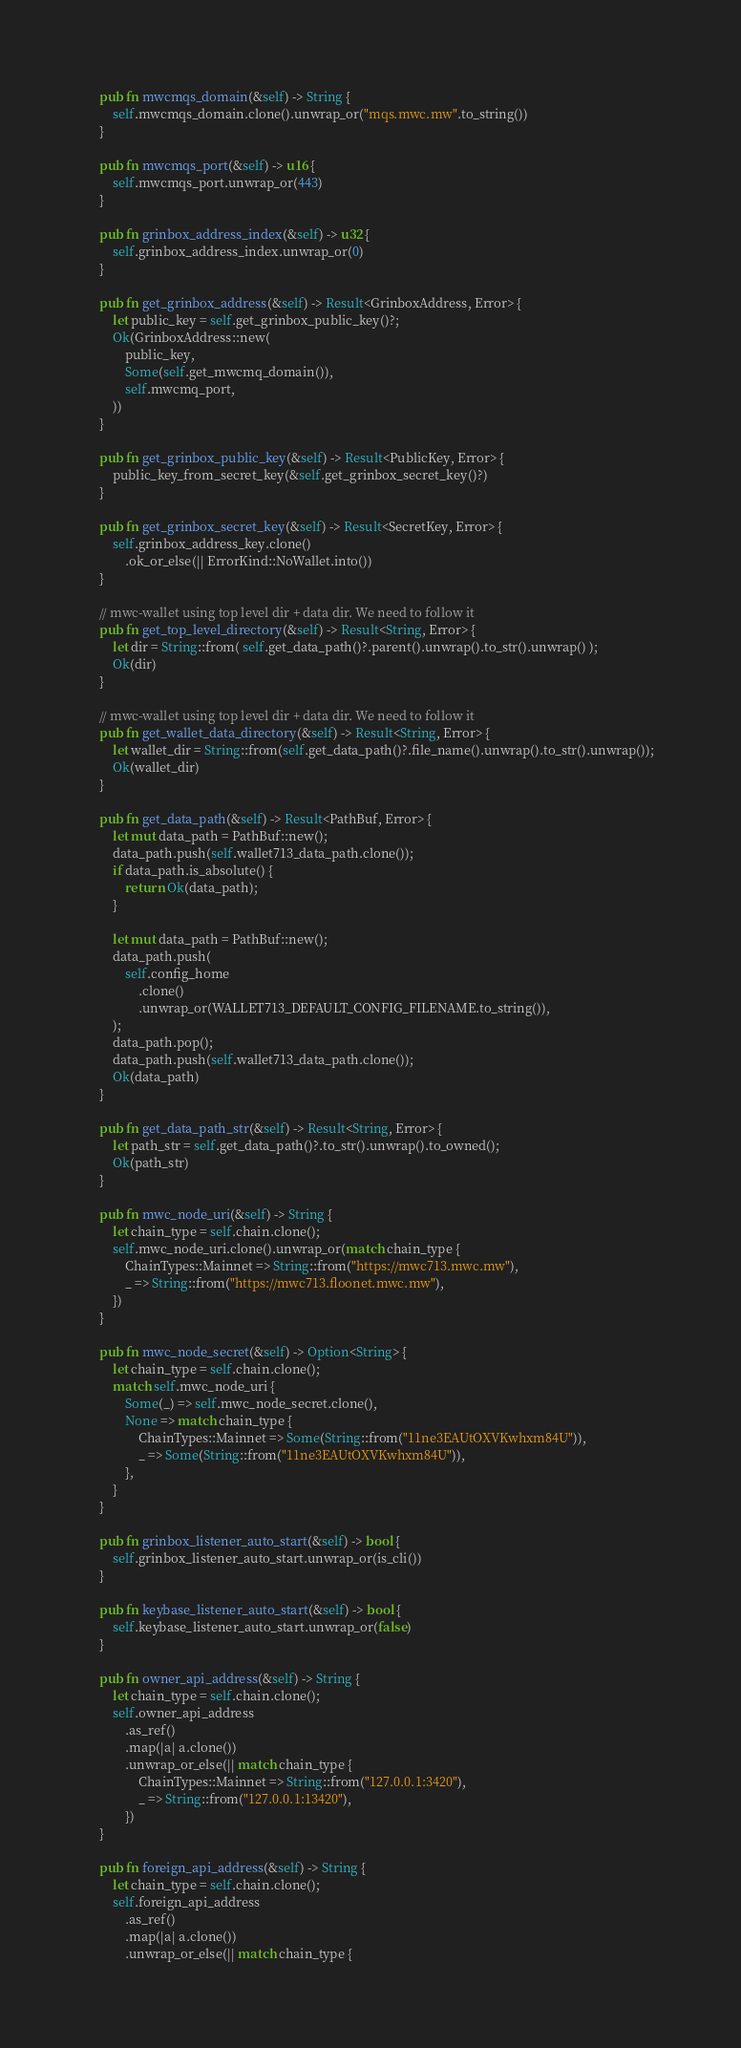Convert code to text. <code><loc_0><loc_0><loc_500><loc_500><_Rust_>
    pub fn mwcmqs_domain(&self) -> String {
        self.mwcmqs_domain.clone().unwrap_or("mqs.mwc.mw".to_string())
    }

    pub fn mwcmqs_port(&self) -> u16 {
        self.mwcmqs_port.unwrap_or(443)
    }

    pub fn grinbox_address_index(&self) -> u32 {
        self.grinbox_address_index.unwrap_or(0)
    }

    pub fn get_grinbox_address(&self) -> Result<GrinboxAddress, Error> {
        let public_key = self.get_grinbox_public_key()?;
        Ok(GrinboxAddress::new(
            public_key,
            Some(self.get_mwcmq_domain()),
            self.mwcmq_port,
        ))
    }

    pub fn get_grinbox_public_key(&self) -> Result<PublicKey, Error> {
        public_key_from_secret_key(&self.get_grinbox_secret_key()?)
    }

    pub fn get_grinbox_secret_key(&self) -> Result<SecretKey, Error> {
        self.grinbox_address_key.clone()
            .ok_or_else(|| ErrorKind::NoWallet.into())
    }

    // mwc-wallet using top level dir + data dir. We need to follow it
    pub fn get_top_level_directory(&self) -> Result<String, Error> {
        let dir = String::from( self.get_data_path()?.parent().unwrap().to_str().unwrap() );
        Ok(dir)
    }

    // mwc-wallet using top level dir + data dir. We need to follow it
    pub fn get_wallet_data_directory(&self) -> Result<String, Error> {
        let wallet_dir = String::from(self.get_data_path()?.file_name().unwrap().to_str().unwrap());
        Ok(wallet_dir)
    }

    pub fn get_data_path(&self) -> Result<PathBuf, Error> {
        let mut data_path = PathBuf::new();
        data_path.push(self.wallet713_data_path.clone());
        if data_path.is_absolute() {
            return Ok(data_path);
        }

        let mut data_path = PathBuf::new();
        data_path.push(
            self.config_home
                .clone()
                .unwrap_or(WALLET713_DEFAULT_CONFIG_FILENAME.to_string()),
        );
        data_path.pop();
        data_path.push(self.wallet713_data_path.clone());
        Ok(data_path)
    }

    pub fn get_data_path_str(&self) -> Result<String, Error> {
        let path_str = self.get_data_path()?.to_str().unwrap().to_owned();
        Ok(path_str)
    }

    pub fn mwc_node_uri(&self) -> String {
        let chain_type = self.chain.clone();
        self.mwc_node_uri.clone().unwrap_or(match chain_type {
            ChainTypes::Mainnet => String::from("https://mwc713.mwc.mw"),
            _ => String::from("https://mwc713.floonet.mwc.mw"),
        })
    }

    pub fn mwc_node_secret(&self) -> Option<String> {
        let chain_type = self.chain.clone();
        match self.mwc_node_uri {
            Some(_) => self.mwc_node_secret.clone(),
            None => match chain_type {
                ChainTypes::Mainnet => Some(String::from("11ne3EAUtOXVKwhxm84U")),
                _ => Some(String::from("11ne3EAUtOXVKwhxm84U")),
            },
        }
    }

    pub fn grinbox_listener_auto_start(&self) -> bool {
        self.grinbox_listener_auto_start.unwrap_or(is_cli())
    }

    pub fn keybase_listener_auto_start(&self) -> bool {
        self.keybase_listener_auto_start.unwrap_or(false)
    }

    pub fn owner_api_address(&self) -> String {
        let chain_type = self.chain.clone();
        self.owner_api_address
            .as_ref()
            .map(|a| a.clone())
            .unwrap_or_else(|| match chain_type {
                ChainTypes::Mainnet => String::from("127.0.0.1:3420"),
                _ => String::from("127.0.0.1:13420"),
            })
    }

    pub fn foreign_api_address(&self) -> String {
        let chain_type = self.chain.clone();
        self.foreign_api_address
            .as_ref()
            .map(|a| a.clone())
            .unwrap_or_else(|| match chain_type {</code> 